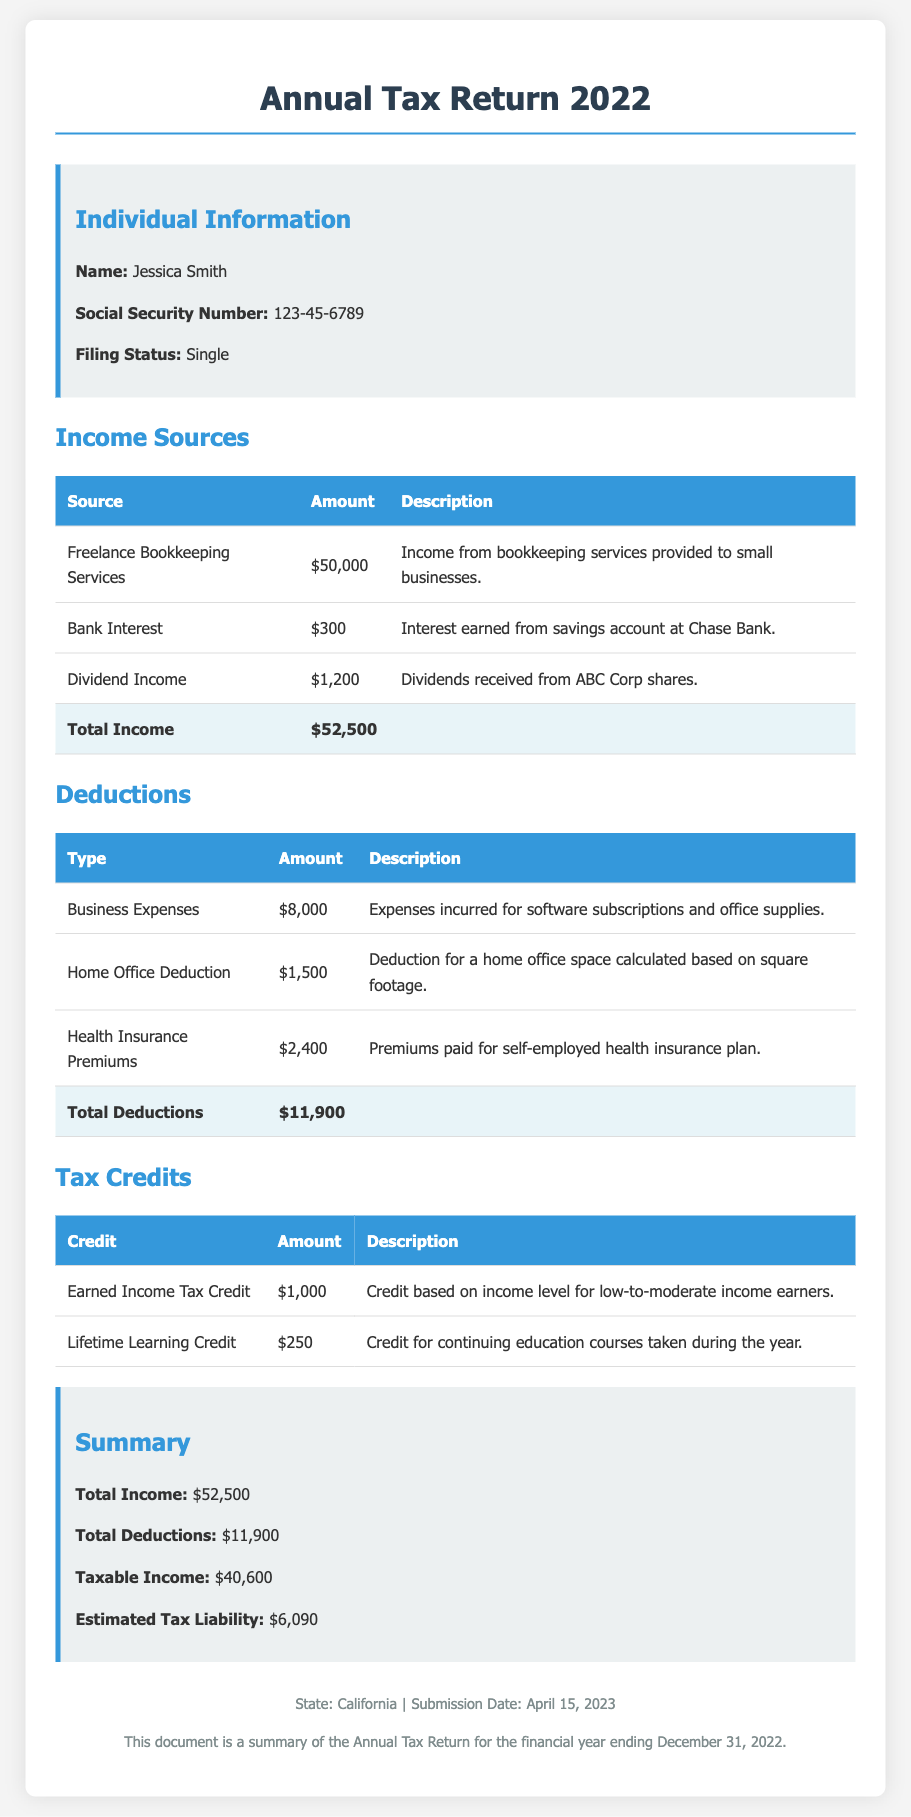What is the name of the individual? The document presents the name of the individual as Jessica Smith.
Answer: Jessica Smith What is the total income? The total income is listed as the sum of all income sources in the document, which amounts to $52,500.
Answer: $52,500 How much is the Business Expenses deduction? The document specifies the amount for Business Expenses as $8,000.
Answer: $8,000 What is the estimated tax liability? The estimated tax liability is highlighted in the summary section as $6,090.
Answer: $6,090 What type of tax credit is mentioned for education courses? The document lists the Lifetime Learning Credit as a type of tax credit for continuing education courses.
Answer: Lifetime Learning Credit What is the filing status of the individual? The document indicates the filing status of the individual as Single.
Answer: Single What is the total amount of deductions? The total deductions are summarized in the document as $11,900.
Answer: $11,900 When was the document submitted? The submission date provided in the footer of the document is April 15, 2023.
Answer: April 15, 2023 How much is the Earned Income Tax Credit? The document states the amount for the Earned Income Tax Credit as $1,000.
Answer: $1,000 